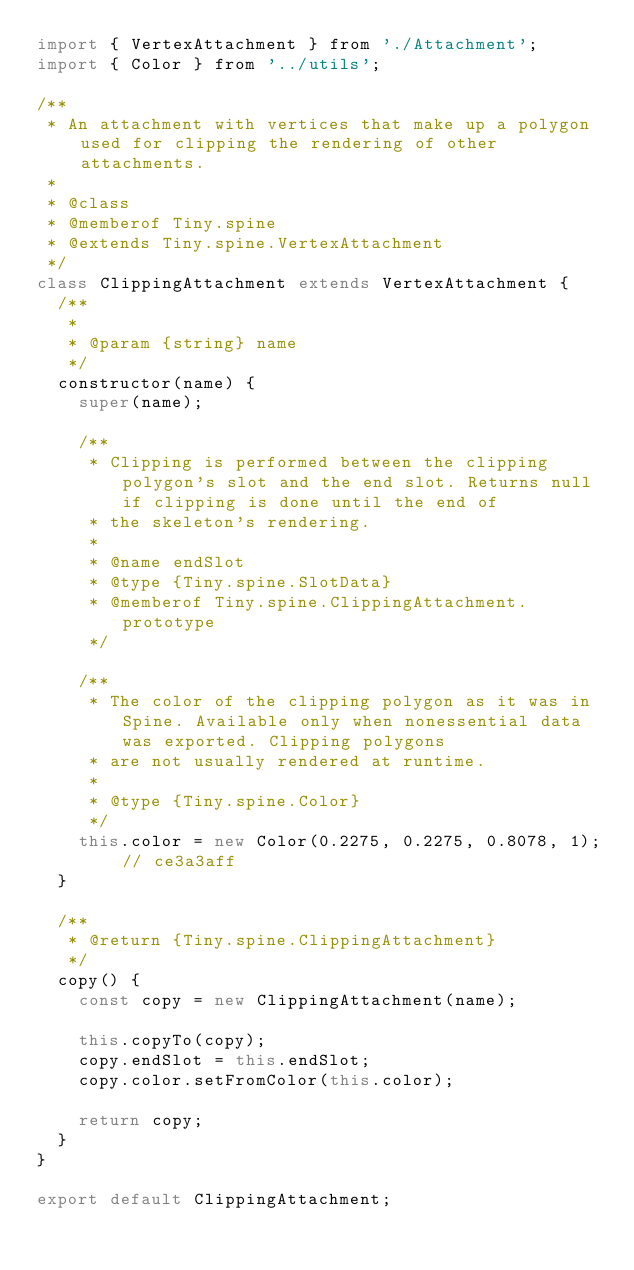<code> <loc_0><loc_0><loc_500><loc_500><_JavaScript_>import { VertexAttachment } from './Attachment';
import { Color } from '../utils';

/**
 * An attachment with vertices that make up a polygon used for clipping the rendering of other attachments.
 *
 * @class
 * @memberof Tiny.spine
 * @extends Tiny.spine.VertexAttachment
 */
class ClippingAttachment extends VertexAttachment {
  /**
   *
   * @param {string} name
   */
  constructor(name) {
    super(name);

    /**
     * Clipping is performed between the clipping polygon's slot and the end slot. Returns null if clipping is done until the end of
     * the skeleton's rendering.
     *
     * @name endSlot
     * @type {Tiny.spine.SlotData}
     * @memberof Tiny.spine.ClippingAttachment.prototype
     */

    /**
     * The color of the clipping polygon as it was in Spine. Available only when nonessential data was exported. Clipping polygons
     * are not usually rendered at runtime.
     *
     * @type {Tiny.spine.Color}
     */
    this.color = new Color(0.2275, 0.2275, 0.8078, 1); // ce3a3aff
  }

  /**
   * @return {Tiny.spine.ClippingAttachment}
   */
  copy() {
    const copy = new ClippingAttachment(name);

    this.copyTo(copy);
    copy.endSlot = this.endSlot;
    copy.color.setFromColor(this.color);

    return copy;
  }
}

export default ClippingAttachment;
</code> 